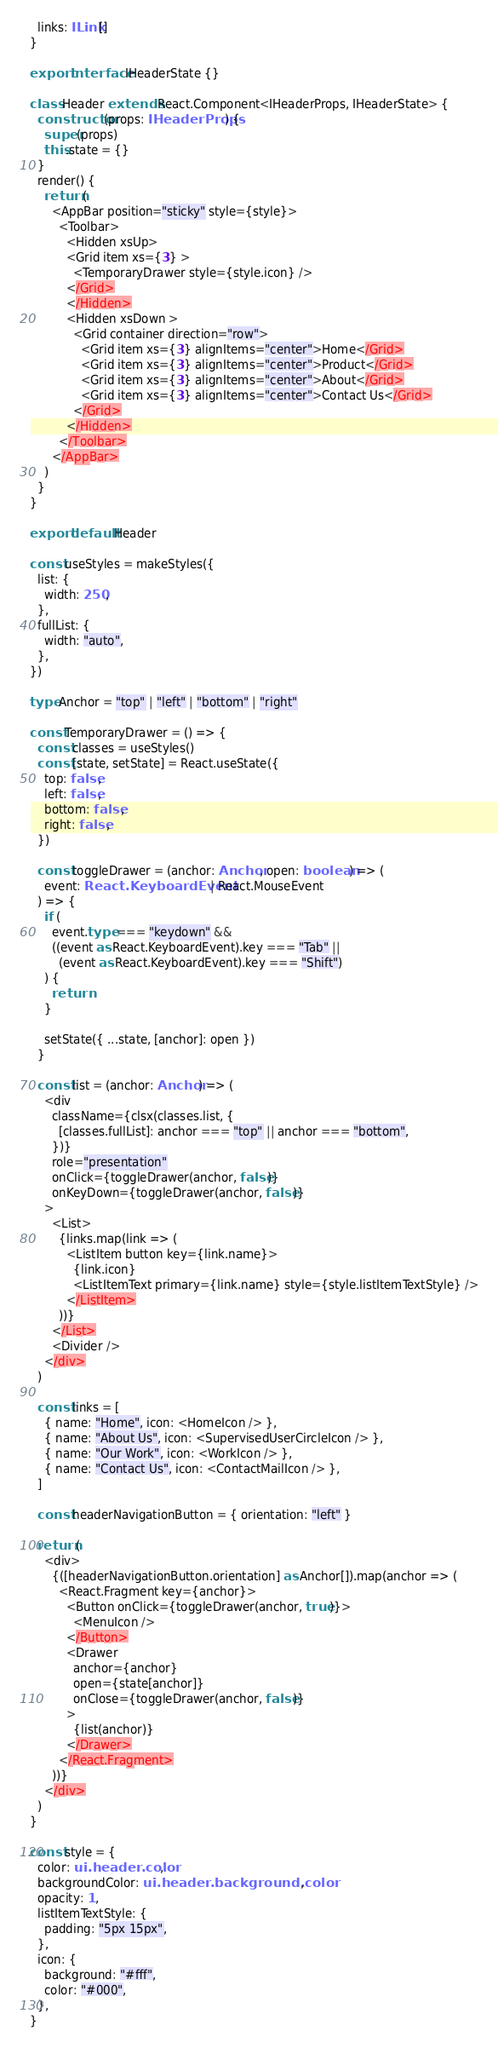Convert code to text. <code><loc_0><loc_0><loc_500><loc_500><_TypeScript_>  links: ILink[]
}

export interface IHeaderState {}

class Header extends React.Component<IHeaderProps, IHeaderState> {
  constructor(props: IHeaderProps) {
    super(props)
    this.state = {}
  }
  render() {
    return (
      <AppBar position="sticky" style={style}>
        <Toolbar>
          <Hidden xsUp>
          <Grid item xs={3} >
            <TemporaryDrawer style={style.icon} />
          </Grid>
          </Hidden>
          <Hidden xsDown >
            <Grid container direction="row">
              <Grid item xs={3} alignItems="center">Home</Grid>
              <Grid item xs={3} alignItems="center">Product</Grid>
              <Grid item xs={3} alignItems="center">About</Grid>
              <Grid item xs={3} alignItems="center">Contact Us</Grid>
            </Grid>
          </Hidden>
        </Toolbar>
      </AppBar>
    )
  }
}

export default Header

const useStyles = makeStyles({
  list: {
    width: 250,
  },
  fullList: {
    width: "auto",
  },
})

type Anchor = "top" | "left" | "bottom" | "right"

const TemporaryDrawer = () => {
  const classes = useStyles()
  const [state, setState] = React.useState({
    top: false,
    left: false,
    bottom: false,
    right: false,
  })

  const toggleDrawer = (anchor: Anchor, open: boolean) => (
    event: React.KeyboardEvent | React.MouseEvent
  ) => {
    if (
      event.type === "keydown" &&
      ((event as React.KeyboardEvent).key === "Tab" ||
        (event as React.KeyboardEvent).key === "Shift")
    ) {
      return
    }

    setState({ ...state, [anchor]: open })
  }

  const list = (anchor: Anchor) => (
    <div
      className={clsx(classes.list, {
        [classes.fullList]: anchor === "top" || anchor === "bottom",
      })}
      role="presentation"
      onClick={toggleDrawer(anchor, false)}
      onKeyDown={toggleDrawer(anchor, false)}
    >
      <List>
        {links.map(link => (
          <ListItem button key={link.name}>
            {link.icon}
            <ListItemText primary={link.name} style={style.listItemTextStyle} />
          </ListItem>
        ))}
      </List>
      <Divider />
    </div>
  )

  const links = [
    { name: "Home", icon: <HomeIcon /> },
    { name: "About Us", icon: <SupervisedUserCircleIcon /> },
    { name: "Our Work", icon: <WorkIcon /> },
    { name: "Contact Us", icon: <ContactMailIcon /> },
  ]

  const headerNavigationButton = { orientation: "left" }

  return (
    <div>
      {([headerNavigationButton.orientation] as Anchor[]).map(anchor => (
        <React.Fragment key={anchor}>
          <Button onClick={toggleDrawer(anchor, true)}>
            <MenuIcon />
          </Button>
          <Drawer
            anchor={anchor}
            open={state[anchor]}
            onClose={toggleDrawer(anchor, false)}
          >
            {list(anchor)}
          </Drawer>
        </React.Fragment>
      ))}
    </div>
  )
}

const style = {
  color: ui.header.color,
  backgroundColor: ui.header.background.color,
  opacity: 1,
  listItemTextStyle: {
    padding: "5px 15px",
  },
  icon: {
    background: "#fff",
    color: "#000",
  },
}
</code> 